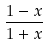<formula> <loc_0><loc_0><loc_500><loc_500>\frac { 1 - x } { 1 + x }</formula> 